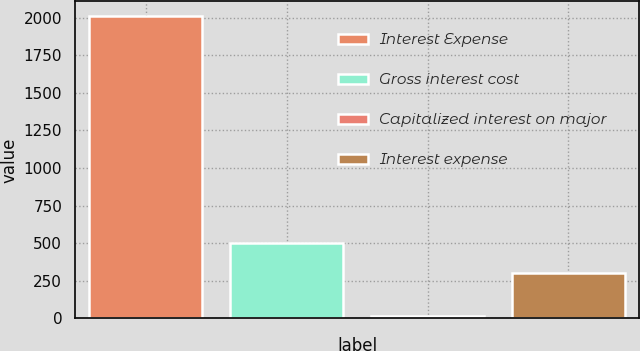Convert chart to OTSL. <chart><loc_0><loc_0><loc_500><loc_500><bar_chart><fcel>Interest Expense<fcel>Gross interest cost<fcel>Capitalized interest on major<fcel>Interest expense<nl><fcel>2008<fcel>503.4<fcel>14<fcel>304<nl></chart> 